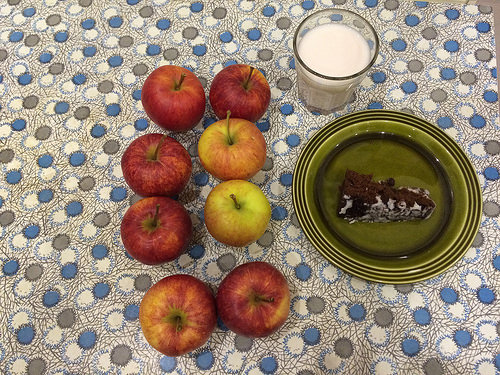<image>
Can you confirm if the cake is next to the milk? Yes. The cake is positioned adjacent to the milk, located nearby in the same general area. 